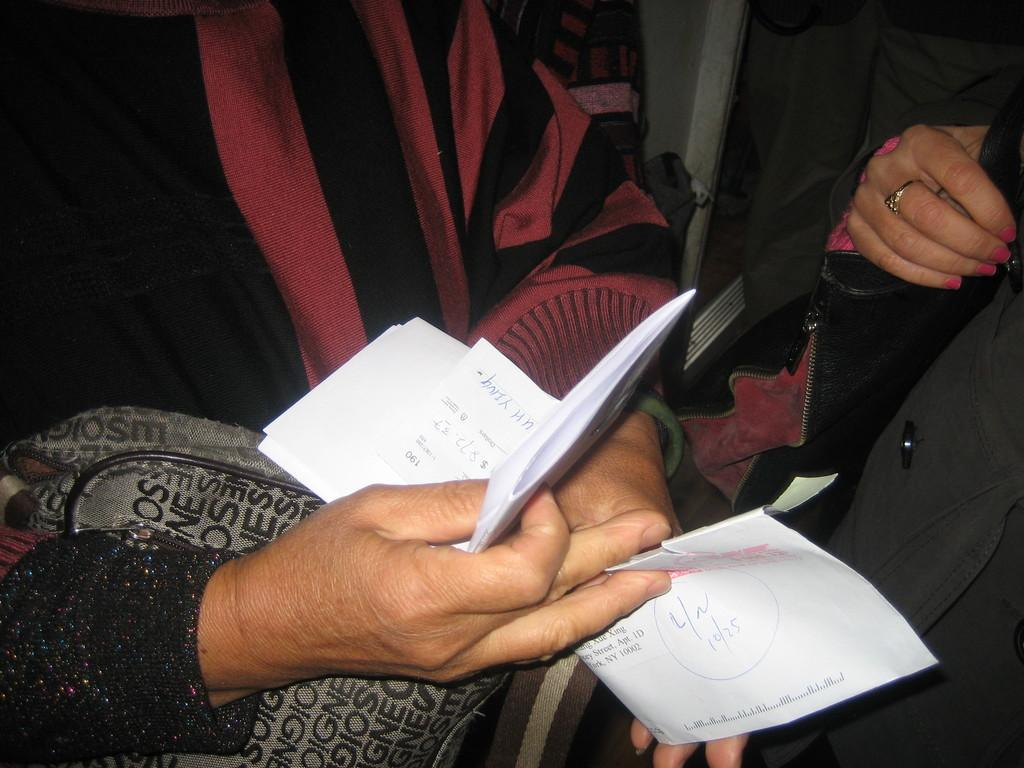What can be seen in the image? There are hands visible in the image. What are the hands holding? The hands are holding papers. Is there a woman in the image kicking a doll? There is not present in the image. 